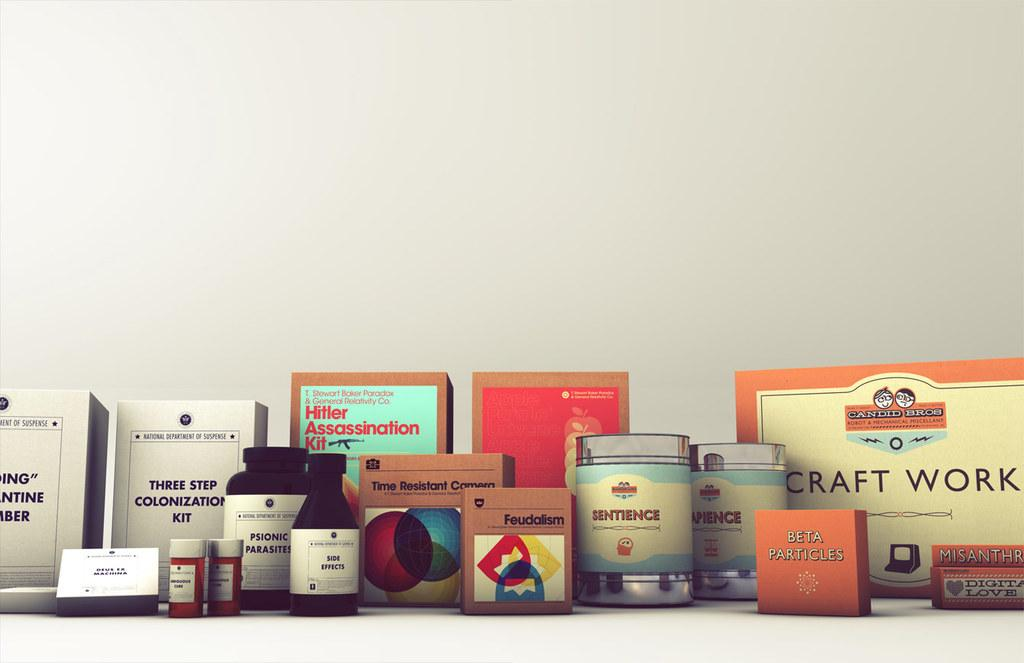<image>
Summarize the visual content of the image. a box that says craft work on it is next to other items 